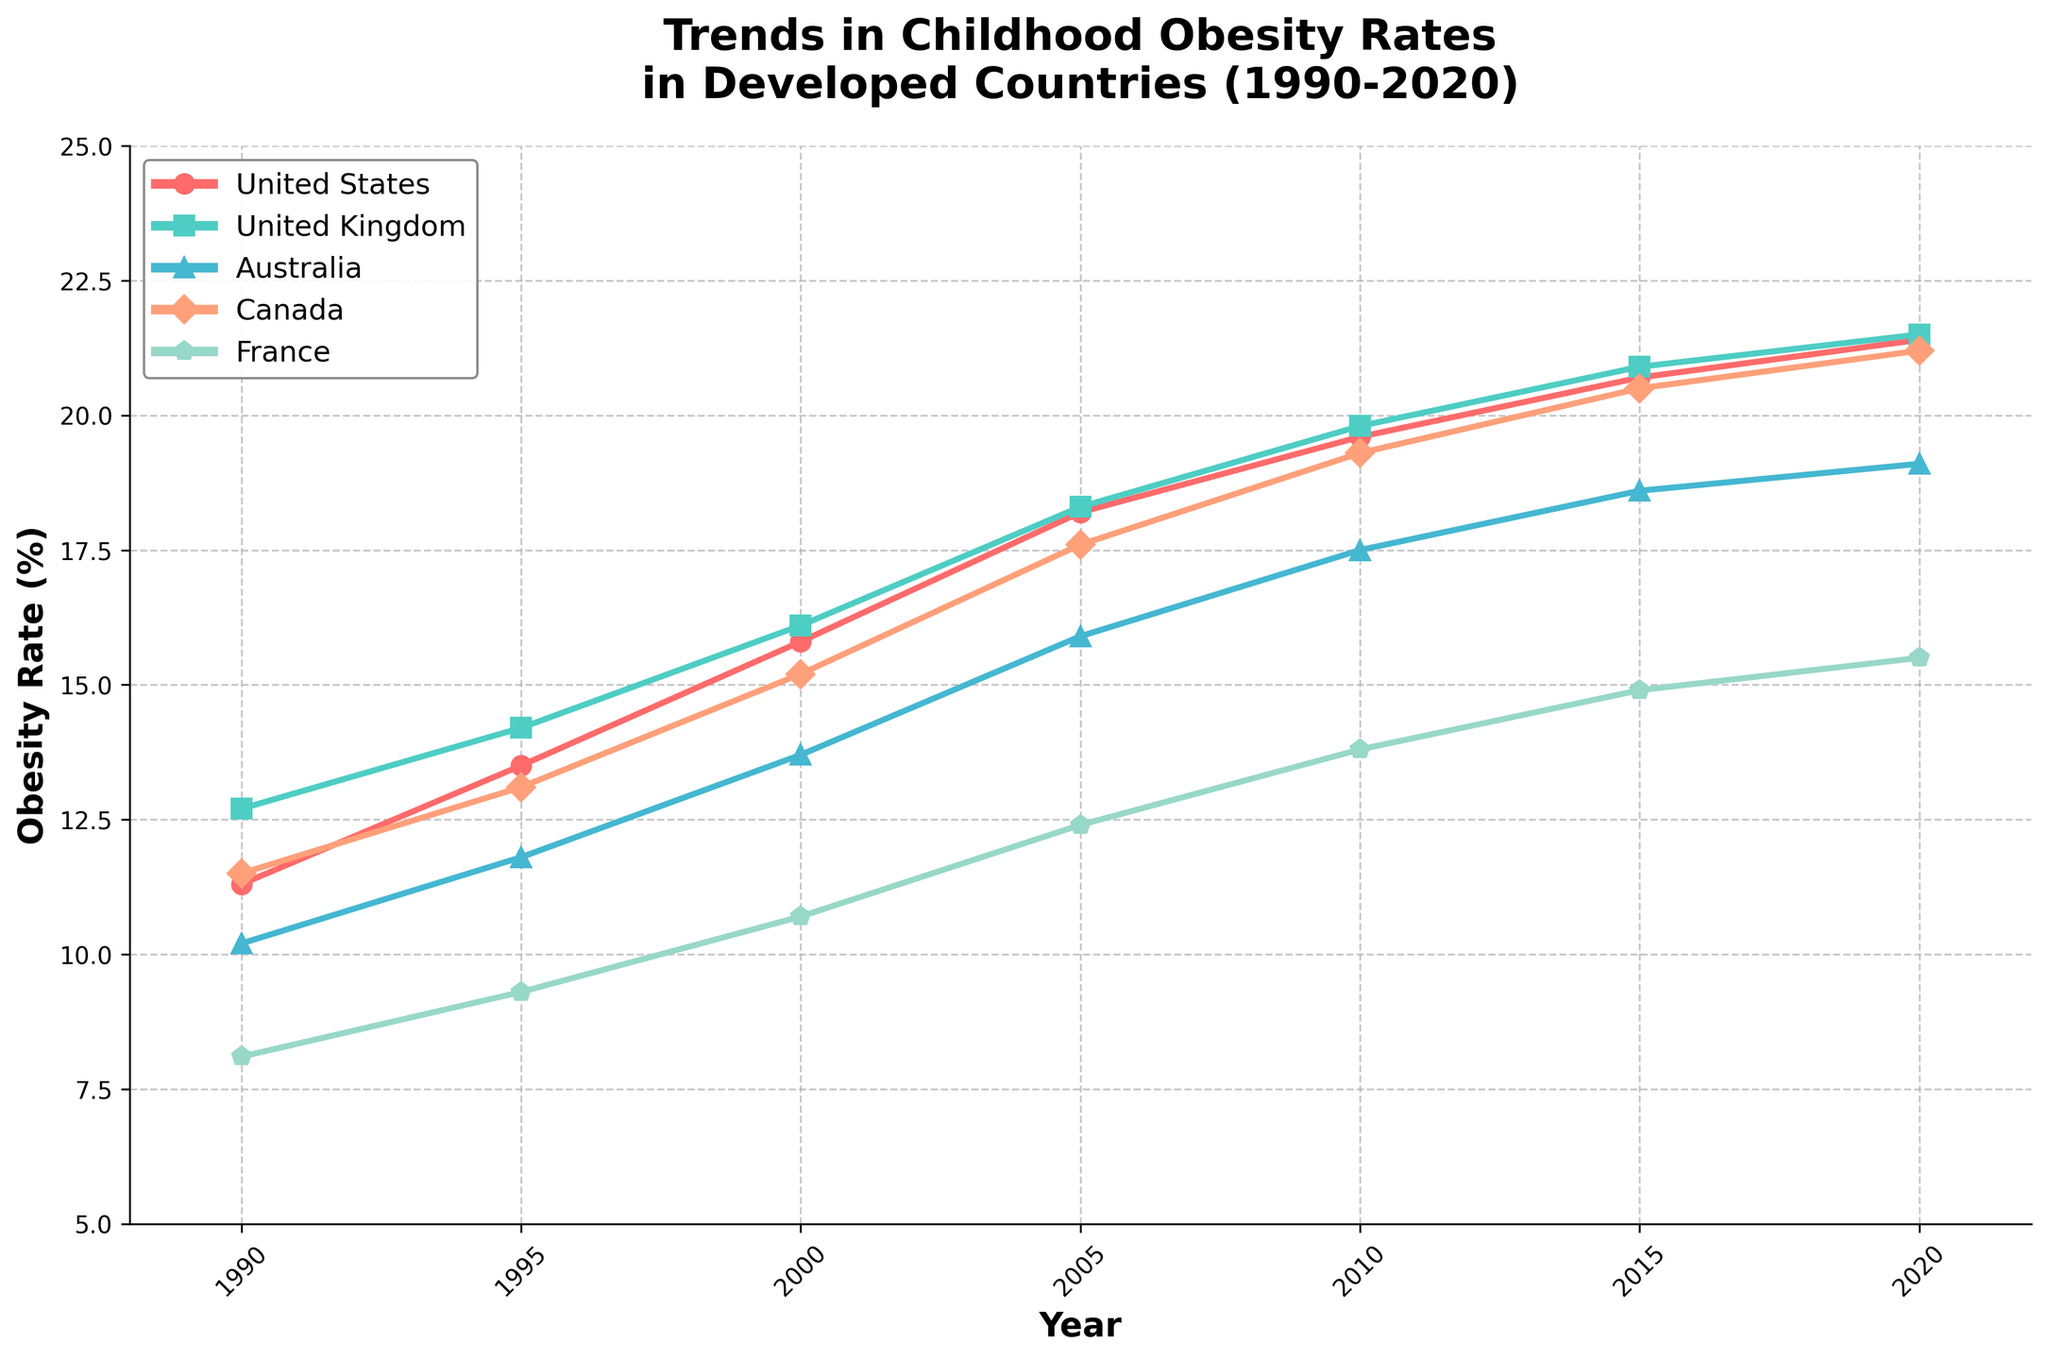What's the trend in childhood obesity rates in the United States over the 30 years? To determine the trend, look at the line for the United States from 1990 to 2020. The line consistently goes upwards, indicating an increase in obesity rates over the 30 years.
Answer: Increasing Which country had the highest childhood obesity rate in 2020? Locate the data points for all countries in the year 2020. The United States has the highest data point in that year.
Answer: United States Between 1990 and 2020, how many countries had a consistent increase in obesity rates? Examine the lines for each country from 1990 to 2020. The United States, United Kingdom, Australia, and Canada lines show consistent increases, whereas France’s line also increases but at a slower rate.
Answer: 5 Did any country have a period of decrease in obesity rates during the 30 years? Check each line for any segments that trend downwards. No lines show a decrease at any interval; all trends are upward.
Answer: No By how much did childhood obesity rates in Australia increase from 1990 to 2020? Find the difference in the obesity rate for Australia between 2020 and 1990 from the chart. The rate increased from 10.2% in 1990 to 19.1% in 2020. 19.1% - 10.2% = 8.9%.
Answer: 8.9% Which country had the lowest obesity rate in 1990, and what was it? Compare the data points for 1990. The lowest rate is in France, with an obesity rate of 8.1%.
Answer: France, 8.1% How does the trend of France's childhood obesity rate compare to that of Canada? Compare the inclination of the lines for France and Canada. Both lines show an increasing trend, but Canada's obesity rate rises more steeply compared to France.
Answer: Both increase; Canada rises more steeply In what year did the United States childhood obesity rate surpass 15%? Locate when the United States line first crosses the 15% mark. This occurs between 1995 and 2000.
Answer: 2000 Which country had the smallest increase in childhood obesity rates from 1990 to 2020? Calculate the increase for each country by finding the difference between 1990 and 2020 data points. France had the smallest increase from 8.1% to 15.5%, which is 7.4%.
Answer: France 